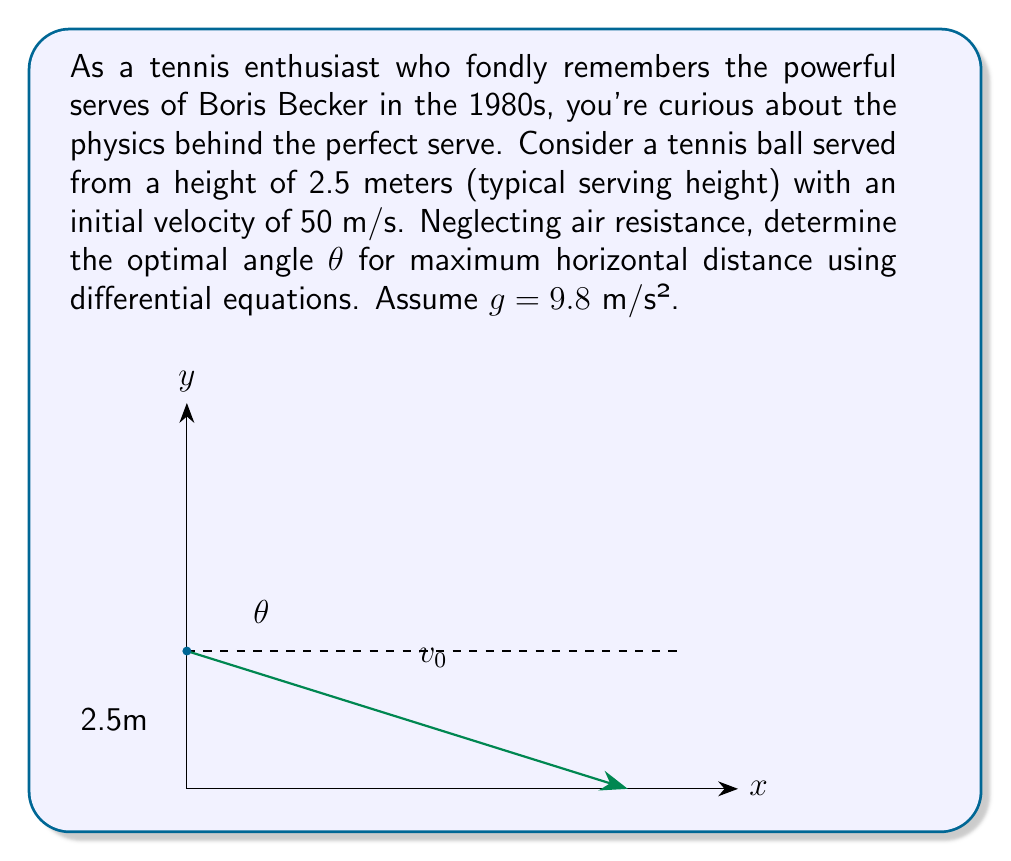Show me your answer to this math problem. Let's approach this step-by-step using differential equations:

1) The equations of motion for projectile motion are:

   $$x(t) = v_0 \cos(\theta) \cdot t$$
   $$y(t) = 2.5 + v_0 \sin(\theta) \cdot t - \frac{1}{2}gt^2$$

2) We want to find the time when the ball hits the ground, i.e., when y(t) = 0:

   $$0 = 2.5 + v_0 \sin(\theta) \cdot t - \frac{1}{2}gt^2$$

3) This is a quadratic equation in t. Solving for t:

   $$t = \frac{v_0 \sin(\theta) + \sqrt{v_0^2 \sin^2(\theta) + 5g}}{g}$$

4) The horizontal distance traveled is x(t) when y(t) = 0:

   $$x = v_0 \cos(\theta) \cdot \frac{v_0 \sin(\theta) + \sqrt{v_0^2 \sin^2(\theta) + 5g}}{g}$$

5) To find the maximum, we differentiate x with respect to θ and set it to zero:

   $$\frac{dx}{d\theta} = 0$$

6) This leads to the equation:

   $$\tan(\theta) = \frac{\sqrt{v_0^2 + 5g} - \sqrt{5g}}{v_0}$$

7) Substituting the given values (v₀ = 50 m/s, g = 9.8 m/s²):

   $$\tan(\theta) = \frac{\sqrt{50^2 + 5(9.8)} - \sqrt{5(9.8)}}{50} \approx 0.8391$$

8) Taking the inverse tangent:

   $$\theta = \tan^{-1}(0.8391) \approx 40.0°$$

Therefore, the optimal angle for maximum horizontal distance is approximately 40.0°.
Answer: $\theta \approx 40.0°$ 